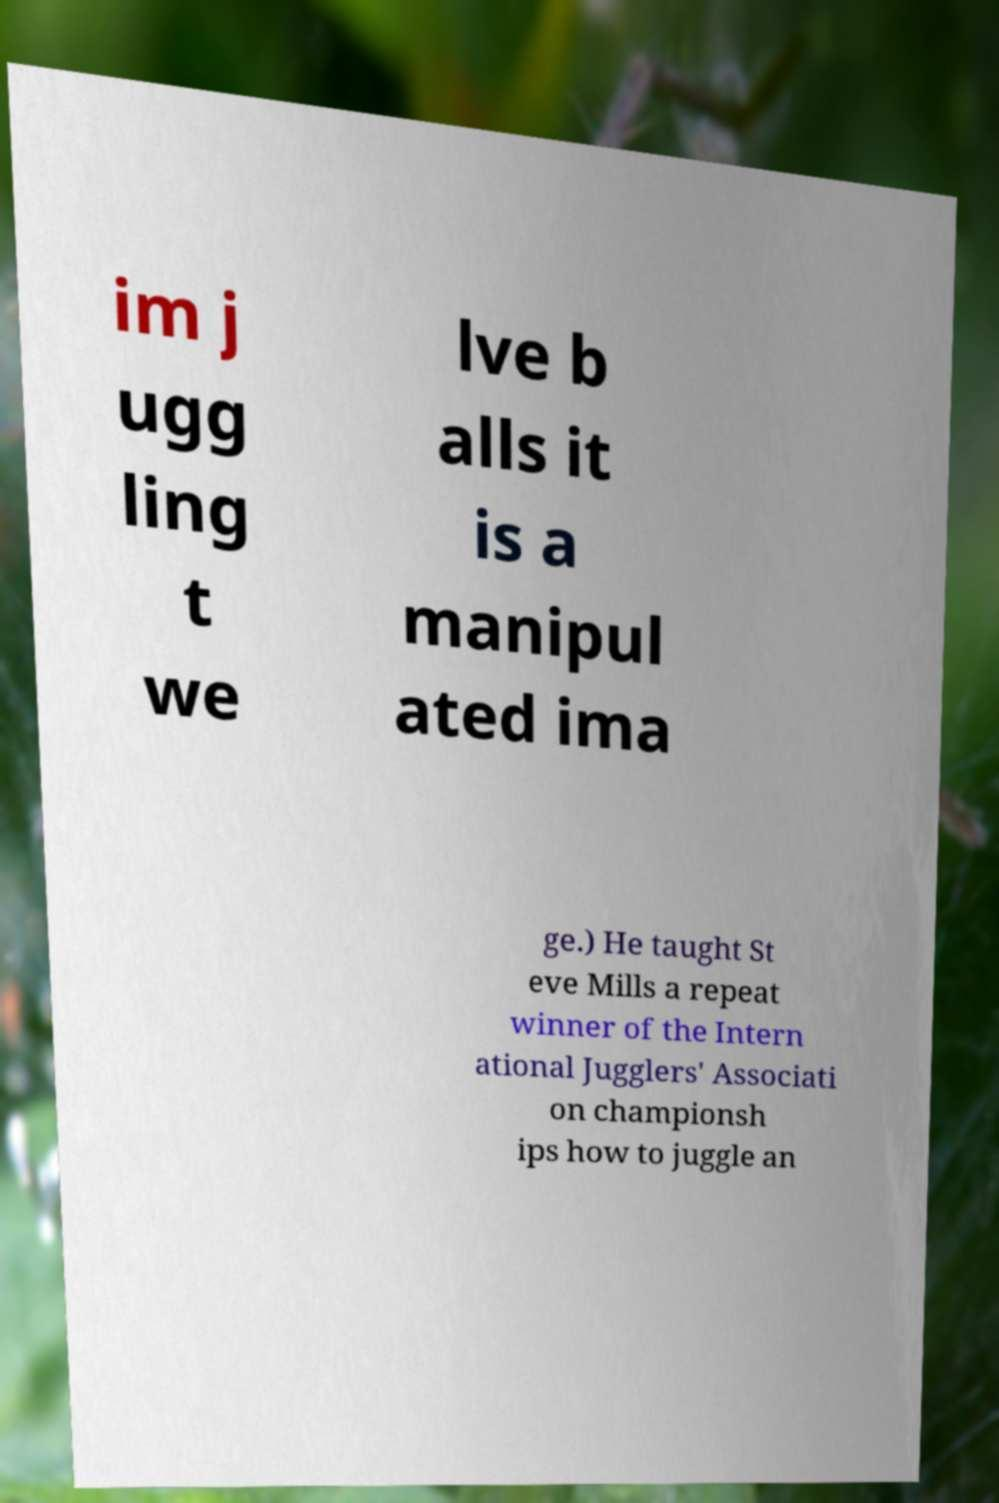There's text embedded in this image that I need extracted. Can you transcribe it verbatim? im j ugg ling t we lve b alls it is a manipul ated ima ge.) He taught St eve Mills a repeat winner of the Intern ational Jugglers' Associati on championsh ips how to juggle an 